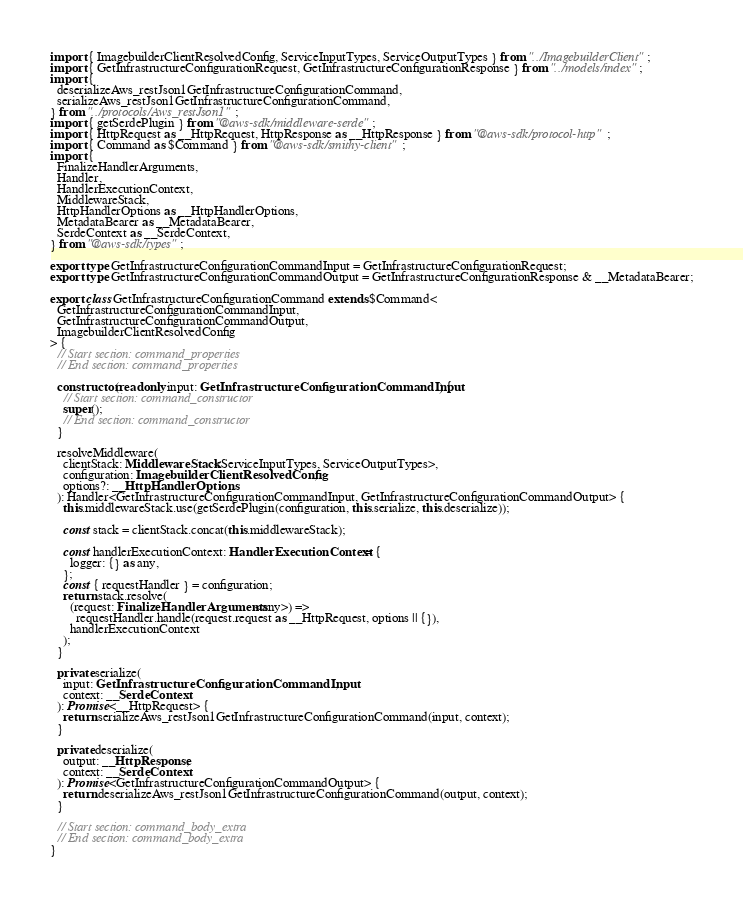Convert code to text. <code><loc_0><loc_0><loc_500><loc_500><_TypeScript_>import { ImagebuilderClientResolvedConfig, ServiceInputTypes, ServiceOutputTypes } from "../ImagebuilderClient";
import { GetInfrastructureConfigurationRequest, GetInfrastructureConfigurationResponse } from "../models/index";
import {
  deserializeAws_restJson1GetInfrastructureConfigurationCommand,
  serializeAws_restJson1GetInfrastructureConfigurationCommand,
} from "../protocols/Aws_restJson1";
import { getSerdePlugin } from "@aws-sdk/middleware-serde";
import { HttpRequest as __HttpRequest, HttpResponse as __HttpResponse } from "@aws-sdk/protocol-http";
import { Command as $Command } from "@aws-sdk/smithy-client";
import {
  FinalizeHandlerArguments,
  Handler,
  HandlerExecutionContext,
  MiddlewareStack,
  HttpHandlerOptions as __HttpHandlerOptions,
  MetadataBearer as __MetadataBearer,
  SerdeContext as __SerdeContext,
} from "@aws-sdk/types";

export type GetInfrastructureConfigurationCommandInput = GetInfrastructureConfigurationRequest;
export type GetInfrastructureConfigurationCommandOutput = GetInfrastructureConfigurationResponse & __MetadataBearer;

export class GetInfrastructureConfigurationCommand extends $Command<
  GetInfrastructureConfigurationCommandInput,
  GetInfrastructureConfigurationCommandOutput,
  ImagebuilderClientResolvedConfig
> {
  // Start section: command_properties
  // End section: command_properties

  constructor(readonly input: GetInfrastructureConfigurationCommandInput) {
    // Start section: command_constructor
    super();
    // End section: command_constructor
  }

  resolveMiddleware(
    clientStack: MiddlewareStack<ServiceInputTypes, ServiceOutputTypes>,
    configuration: ImagebuilderClientResolvedConfig,
    options?: __HttpHandlerOptions
  ): Handler<GetInfrastructureConfigurationCommandInput, GetInfrastructureConfigurationCommandOutput> {
    this.middlewareStack.use(getSerdePlugin(configuration, this.serialize, this.deserialize));

    const stack = clientStack.concat(this.middlewareStack);

    const handlerExecutionContext: HandlerExecutionContext = {
      logger: {} as any,
    };
    const { requestHandler } = configuration;
    return stack.resolve(
      (request: FinalizeHandlerArguments<any>) =>
        requestHandler.handle(request.request as __HttpRequest, options || {}),
      handlerExecutionContext
    );
  }

  private serialize(
    input: GetInfrastructureConfigurationCommandInput,
    context: __SerdeContext
  ): Promise<__HttpRequest> {
    return serializeAws_restJson1GetInfrastructureConfigurationCommand(input, context);
  }

  private deserialize(
    output: __HttpResponse,
    context: __SerdeContext
  ): Promise<GetInfrastructureConfigurationCommandOutput> {
    return deserializeAws_restJson1GetInfrastructureConfigurationCommand(output, context);
  }

  // Start section: command_body_extra
  // End section: command_body_extra
}
</code> 